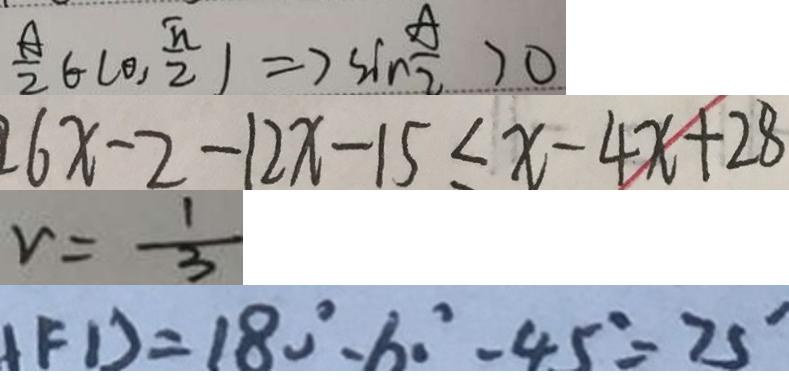Convert formula to latex. <formula><loc_0><loc_0><loc_500><loc_500>\frac { A } { 2 } \in ( 0 , \frac { \pi } { 2 } ) \Rightarrow \sin \frac { A } { 2 } > 0 
 6 x - 2 - 1 2 x - 1 5 \leq x - 4 x + 2 8 
 v = \frac { 1 } { 3 } 
 F D = 1 8 0 ^ { \circ } - 6 0 ^ { \circ } - 4 5 ^ { \circ } = 7 5 ^ { \circ }</formula> 